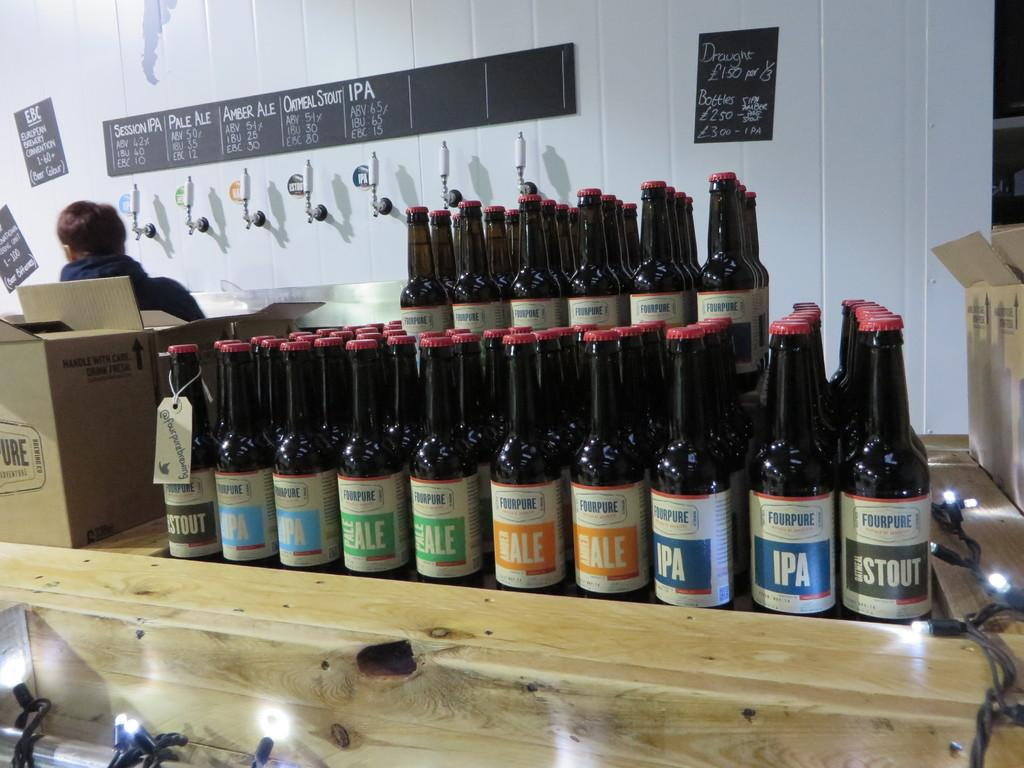<image>
Give a short and clear explanation of the subsequent image. Several bottles of "FOURPURE" are lined up next to each other. 